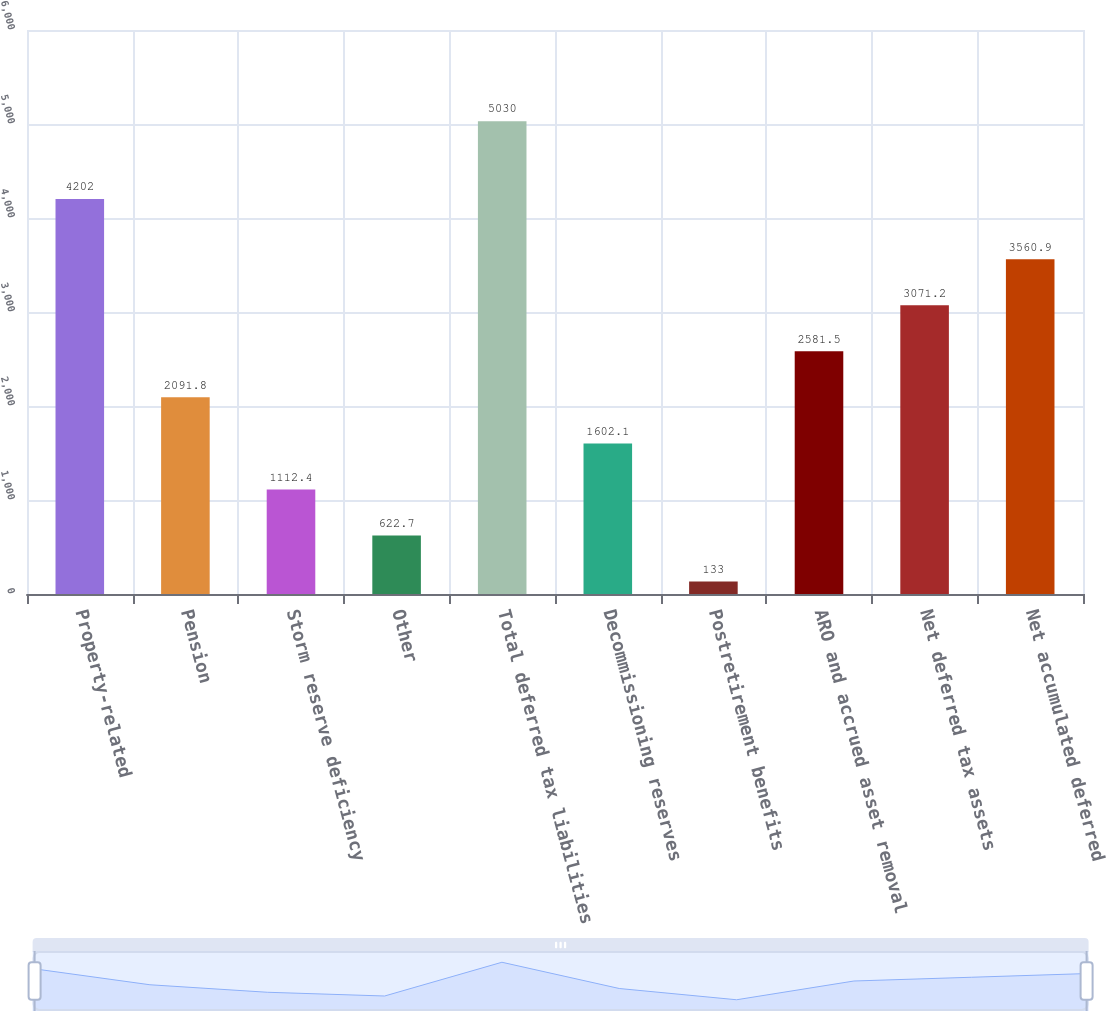Convert chart. <chart><loc_0><loc_0><loc_500><loc_500><bar_chart><fcel>Property-related<fcel>Pension<fcel>Storm reserve deficiency<fcel>Other<fcel>Total deferred tax liabilities<fcel>Decommissioning reserves<fcel>Postretirement benefits<fcel>ARO and accrued asset removal<fcel>Net deferred tax assets<fcel>Net accumulated deferred<nl><fcel>4202<fcel>2091.8<fcel>1112.4<fcel>622.7<fcel>5030<fcel>1602.1<fcel>133<fcel>2581.5<fcel>3071.2<fcel>3560.9<nl></chart> 